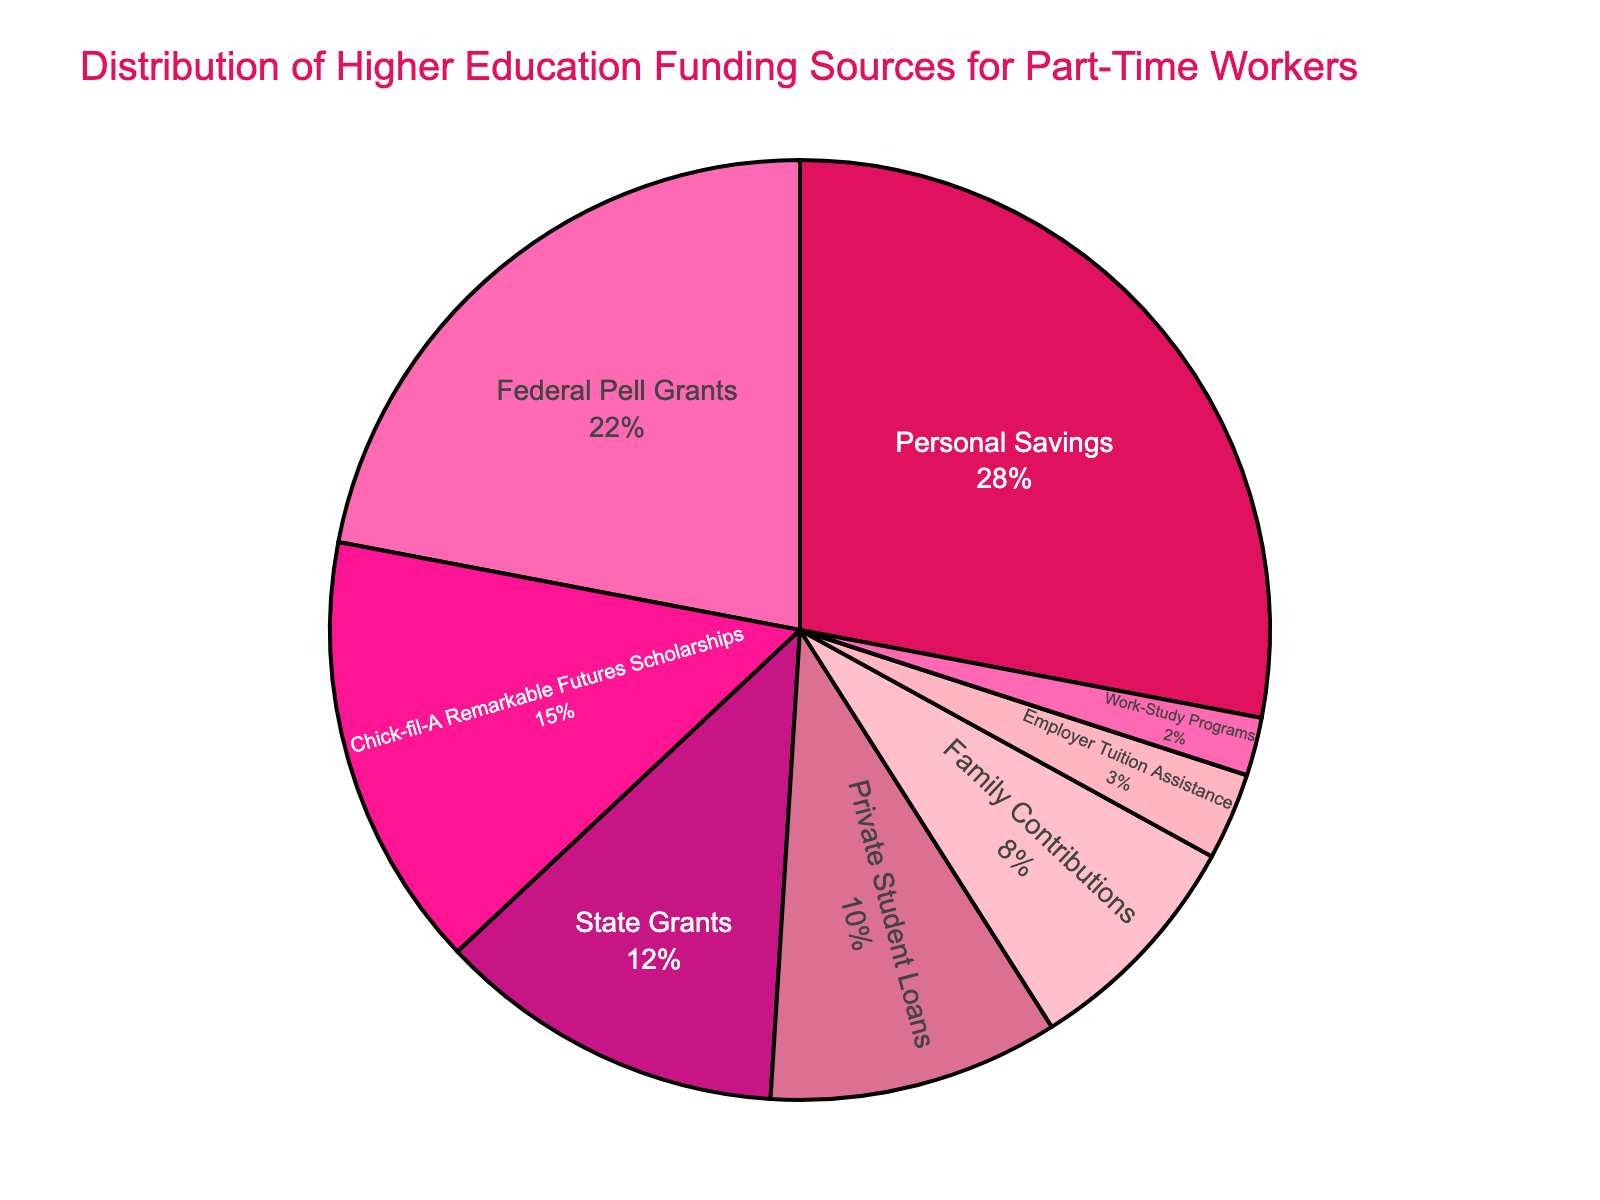What is the largest funding source for part-time workers' higher education? The pie chart shows that the largest segment is labeled "Personal Savings” with 28%.
Answer: Personal Savings Which two funding sources together contribute more than half of the total funding? Looking at the pie chart, "Personal Savings" contributes 28% and "Federal Pell Grants" contributes 22%, summing to 28% + 22% = 50%, which is exactly half. Therefore, we need to include one more source to exceed half. Adding "Chick-fil-A Remarkable Futures Scholarships" (15%) makes 50% + 15% = 65%, accounting for more than half.
Answer: Personal Savings and Federal Pell Grants Is the funding from "Family Contributions" greater than "Work-Study Programs"? From the pie chart, "Family Contributions" is labeled with 8% and "Work-Study Programs" with 2%. Since 8% is greater than 2%, "Family Contributions" is indeed greater than "Work-Study Programs."
Answer: Yes How much higher is the percentage of "State Grants" compared to "Employer Tuition Assistance"? The pie chart indicates "State Grants" at 12% and "Employer Tuition Assistance" at 3%. To find how much higher, calculate the difference: 12% - 3% = 9%.
Answer: 9% What are the colors used to represent "Chick-fil-A Remarkable Futures Scholarships" and "Private Student Loans"? Visually identifying the colors in the pie chart, "Chick-fil-A Remarkable Futures Scholarships" is represented by a bright pink color, while "Private Student Loans" uses a dark pink shade.
Answer: Bright pink and dark pink Which funding sources combine to account for exactly one-third (33%) of the total funding? Starting from the smallest segments, "Employer Tuition Assistance" (3%) + "Work-Study Programs" (2%) = 5%. Adding "Family Contributions" (8%) makes 5% + 8% = 13%. Adding "Private Student Loans" (10%) results in 13% + 10% = 23%. Including "State Grants" (12%) sums the value to be 23% + 12% = 35%. Since we need exactly 33%, a closer look at segments indicates that "Private Student Loans" and "State Grants" alone are closest, contributing 10% + 12% = 22%. Adding "Federal Pell Grants" alongside any one of these surpasses one-third, confirming the cumulative segments didn't include additional combinations. Therefore, there are none accounting exactly for one-third.
Answer: None Which funding source is depicted directly adjacent to "Federal Pell Grants" on the pie chart? Observing the visual positioning reveals that "Chick-fil-A Remarkable Futures Scholarships" is directly adjacent to "Federal Pell Grants."
Answer: Chick-fil-A Remarkable Futures Scholarships Is "Chick-fil-A Remarkable Futures Scholarships" funding greater than "Family Contributions" but less than "State Grants"? According to the pie chart, "Chick-fil-A Remarkable Futures Scholarships" is 15%, "Family Contributions" is 8%, and "State Grants" is 12%. 15% is greater than 8%, but not less than 12%, thereby only one condition of the query is met.
Answer: No 